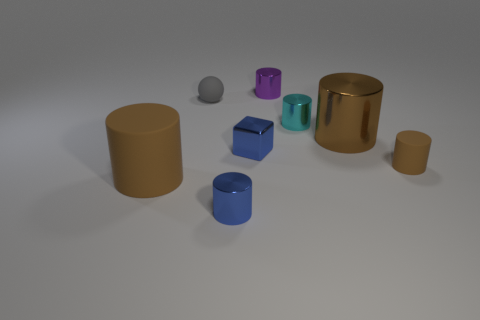Subtract all green blocks. How many brown cylinders are left? 3 Subtract all big metallic cylinders. How many cylinders are left? 5 Subtract all brown cylinders. How many cylinders are left? 3 Add 1 tiny purple metallic cylinders. How many objects exist? 9 Subtract all blue cylinders. Subtract all blue balls. How many cylinders are left? 5 Subtract all balls. How many objects are left? 7 Subtract 0 yellow cylinders. How many objects are left? 8 Subtract all tiny purple cylinders. Subtract all small purple cylinders. How many objects are left? 6 Add 3 small purple metallic objects. How many small purple metallic objects are left? 4 Add 1 big brown balls. How many big brown balls exist? 1 